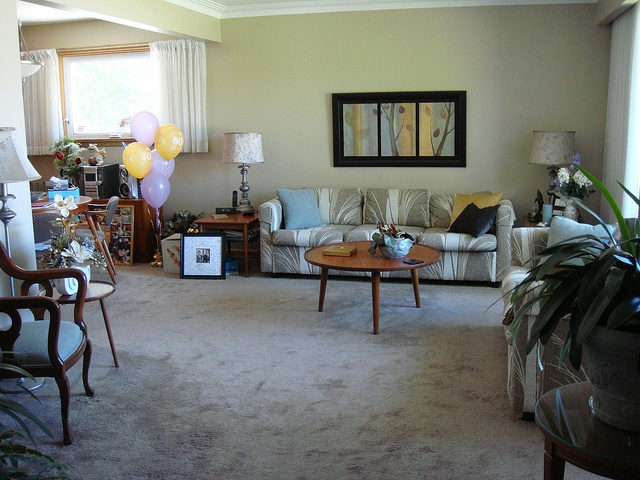Describe the objects in this image and their specific colors. I can see potted plant in beige, black, gray, darkgreen, and darkgray tones, couch in beige, gray, darkgray, and black tones, chair in beige, black, and gray tones, couch in beige, black, gray, and darkgray tones, and dining table in beige, brown, black, maroon, and gray tones in this image. 